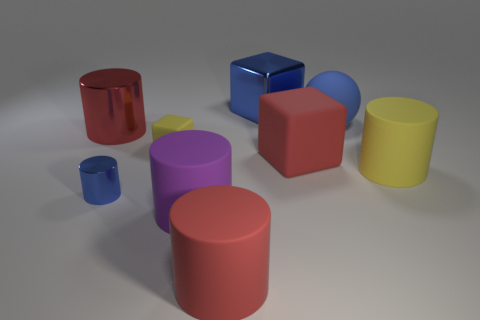Subtract all tiny cylinders. How many cylinders are left? 4 Subtract all red cylinders. How many cylinders are left? 3 Subtract all blue blocks. How many red cylinders are left? 2 Subtract 1 cubes. How many cubes are left? 2 Subtract all cylinders. How many objects are left? 4 Subtract all small purple balls. Subtract all red objects. How many objects are left? 6 Add 3 large metallic cubes. How many large metallic cubes are left? 4 Add 9 tiny blue matte spheres. How many tiny blue matte spheres exist? 9 Subtract 1 yellow cylinders. How many objects are left? 8 Subtract all blue cylinders. Subtract all cyan balls. How many cylinders are left? 4 